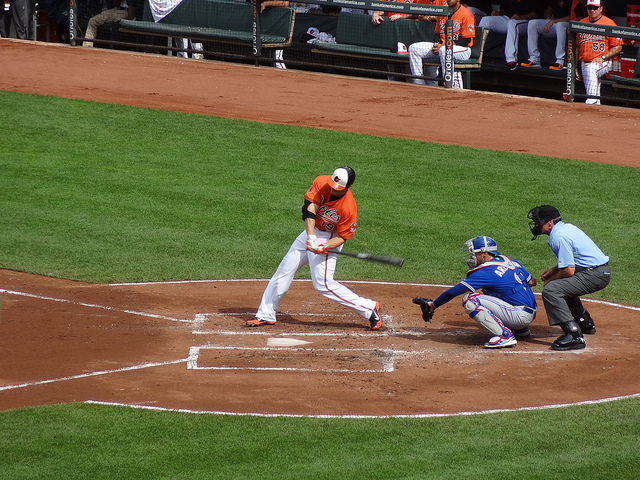What does the catcher's stance indicate about the play? The catcher's stance, crouched low with their mitt presented, is a defensive position prepared to catch a pitched ball, which also suggests they are ready to either catch a strike or a foul tip, or to throw to a base in case of a steal attempt. 